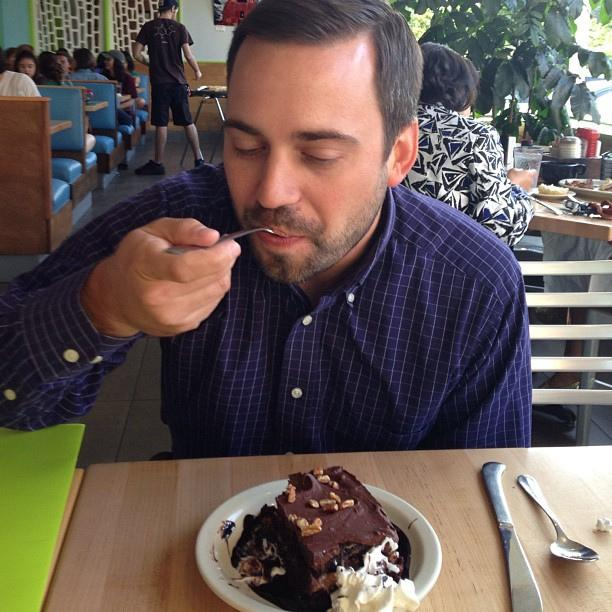What type of restaurant is this? diner 